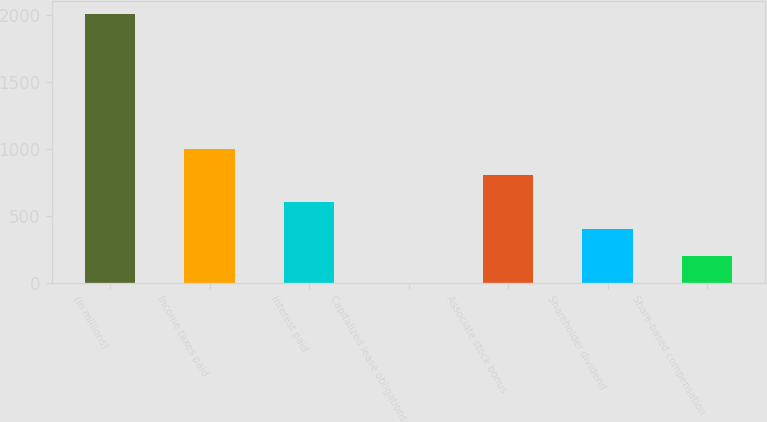<chart> <loc_0><loc_0><loc_500><loc_500><bar_chart><fcel>(In millions)<fcel>Income taxes paid<fcel>Interest paid<fcel>Capitalized lease obligations<fcel>Associate stock bonus<fcel>Shareholder dividend<fcel>Share-based compensation<nl><fcel>2007<fcel>1004<fcel>602.8<fcel>1<fcel>803.4<fcel>402.2<fcel>201.6<nl></chart> 